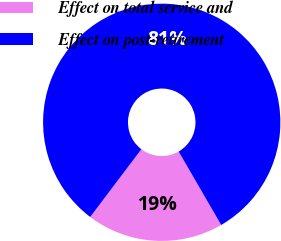Convert chart to OTSL. <chart><loc_0><loc_0><loc_500><loc_500><pie_chart><fcel>Effect on total service and<fcel>Effect on post-retirement<nl><fcel>18.65%<fcel>81.35%<nl></chart> 